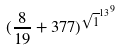Convert formula to latex. <formula><loc_0><loc_0><loc_500><loc_500>( \frac { 8 } { 1 9 } + 3 7 7 ) ^ { { \sqrt { 1 } ^ { 1 3 } } ^ { 9 } }</formula> 